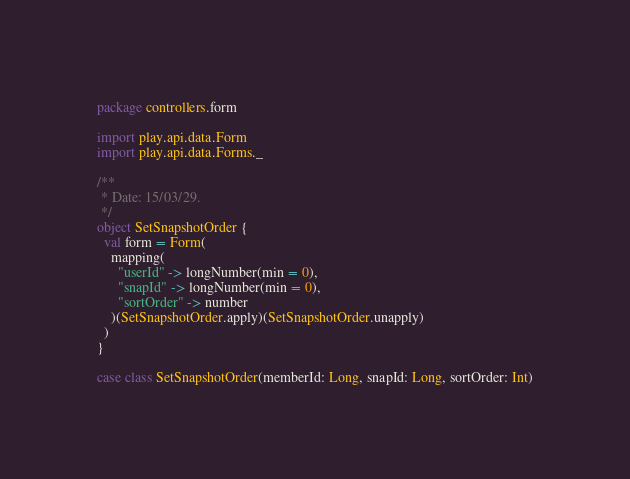Convert code to text. <code><loc_0><loc_0><loc_500><loc_500><_Scala_>package controllers.form

import play.api.data.Form
import play.api.data.Forms._

/**
 * Date: 15/03/29.
 */
object SetSnapshotOrder {
  val form = Form(
    mapping(
      "userId" -> longNumber(min = 0),
      "snapId" -> longNumber(min = 0),
      "sortOrder" -> number
    )(SetSnapshotOrder.apply)(SetSnapshotOrder.unapply)
  )
}

case class SetSnapshotOrder(memberId: Long, snapId: Long, sortOrder: Int)
</code> 